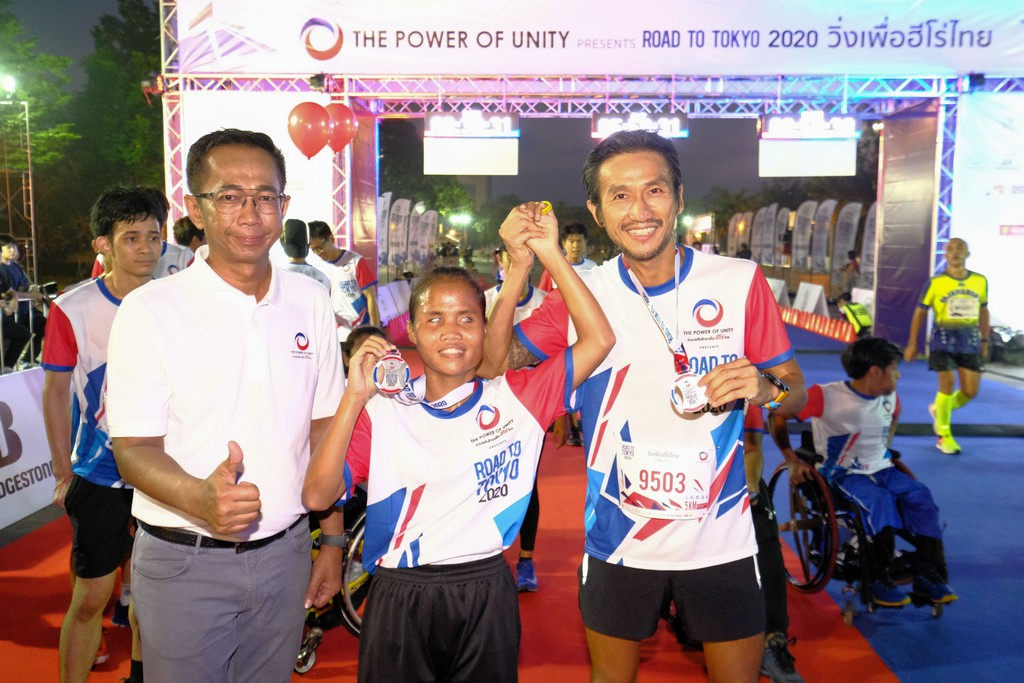How does the lighting and setting of the event affect the overall atmosphere captured in the photograph? The photograph's evening or night-time setting, illuminated by artificial lighting, creates a vibrant and energetic atmosphere that highlights the celebratory mood of the event. This setting not only focuses attention on the participants' expressions and the vivid details of the scene but also adds a sense of excitement and spectacle, typical of major sporting events. The lighting plays a critical role in enriching the visual impact and emotional resonance of the moment, enhancing the participants' achievements and the communal celebration. 